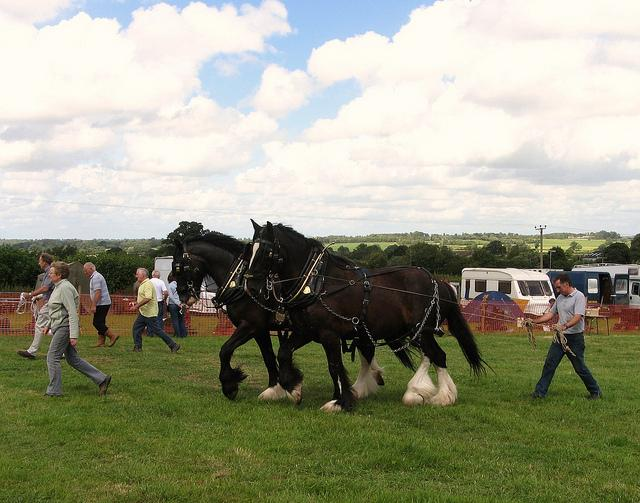Where can the people potentially sleep? campers 